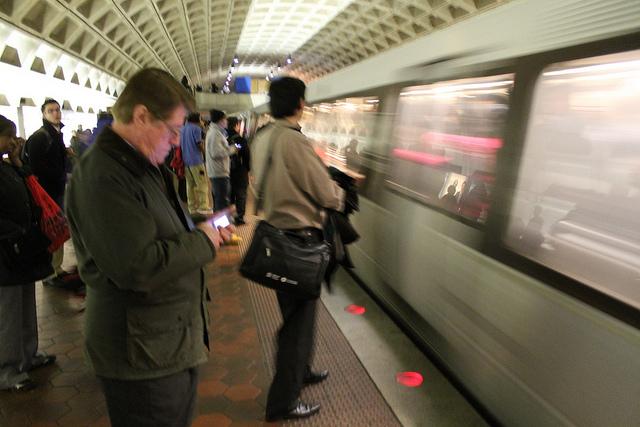Is the train moving?
Write a very short answer. Yes. Are there people in this photo?
Give a very brief answer. Yes. What holiday is associated with the colors of the bags the man is holding?
Short answer required. Christmas. How many people are wearing a black bag?
Be succinct. 1. Is this a subway?
Give a very brief answer. Yes. 